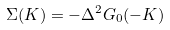<formula> <loc_0><loc_0><loc_500><loc_500>\Sigma ( K ) = - \Delta ^ { 2 } G _ { 0 } ( - K )</formula> 